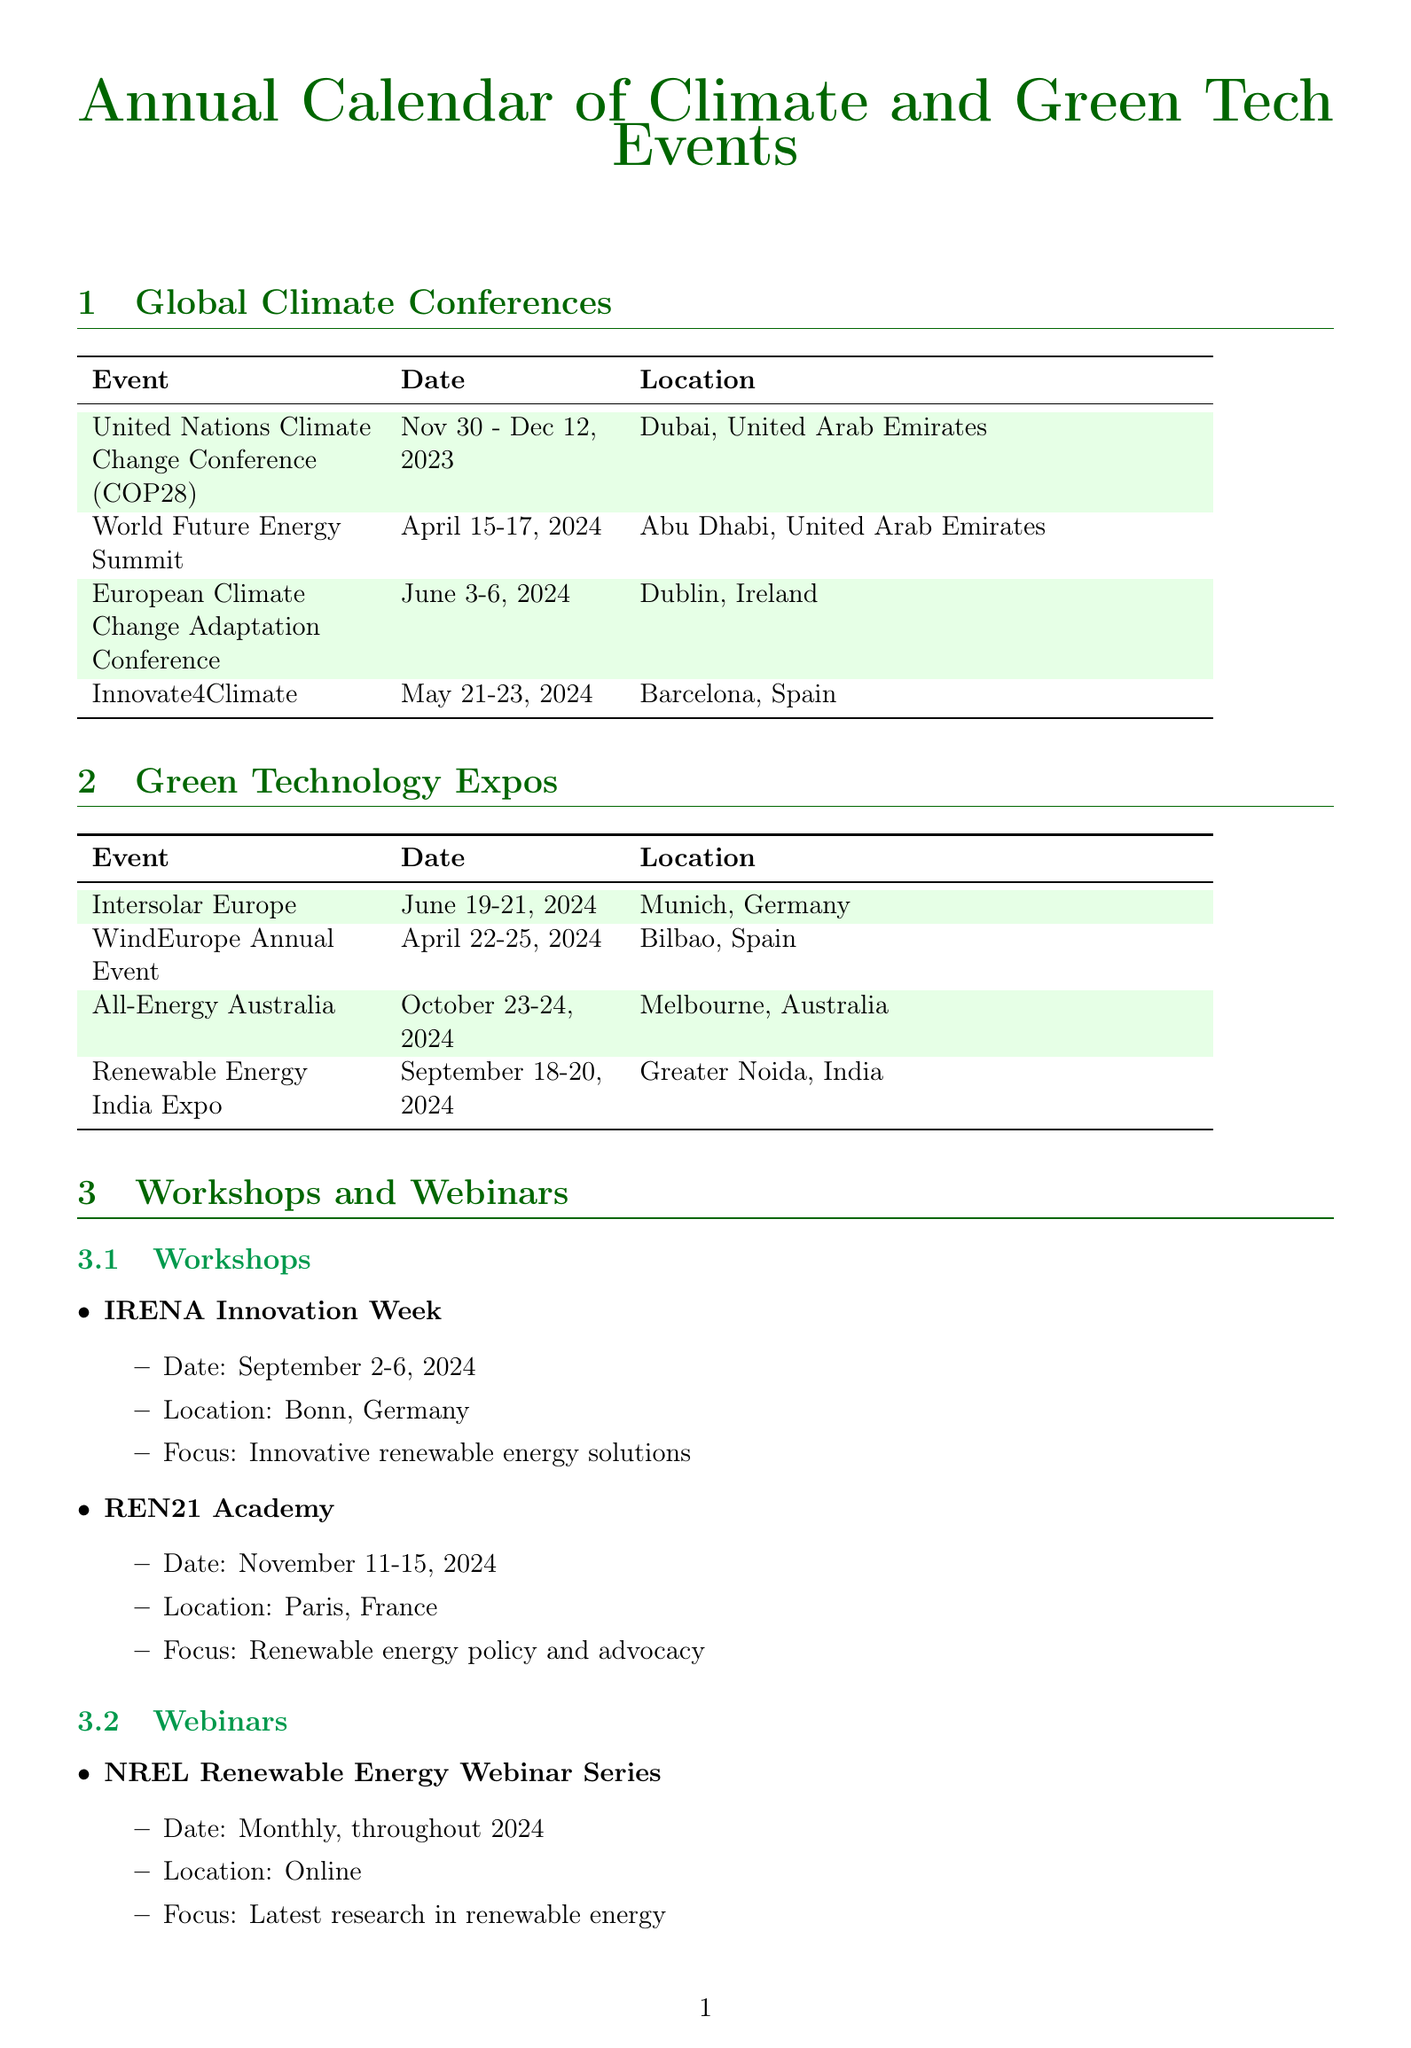What is the date of COP28? The date of COP28 is specified as "November 30 - December 12, 2023".
Answer: November 30 - December 12, 2023 Where will the World Future Energy Summit be held? The location for the World Future Energy Summit is mentioned as "Abu Dhabi, United Arab Emirates".
Answer: Abu Dhabi, United Arab Emirates What type of event is the IREN Innovation Week? It is classified as a "Workshop" focused on "Innovative renewable energy solutions".
Answer: Workshop How many days does the European Climate Change Adaptation Conference last? The dates mentioned are from "June 3-6, 2024", which covers 4 days.
Answer: 4 days What is the primary focus of the NREL Renewable Energy Webinar Series? The focus is described as "Latest research in renewable energy".
Answer: Latest research in renewable energy Which event is scheduled closest to May 2024? "Innovate4Climate", which takes place from "May 21-23, 2024".
Answer: Innovate4Climate What is the location for the WindEurope Annual Event? The location for the WindEurope Annual Event is stated as "Bilbao, Spain".
Answer: Bilbao, Spain How often are the IEA Bioenergy Webinars held throughout 2024? The frequency is specified as "Quarterly, throughout 2024".
Answer: Quarterly What is the relevance of the Renewable Energy India Expo? The relevance is "Insights into renewable energy adoption in developing economies".
Answer: Insights into renewable energy adoption in developing economies 